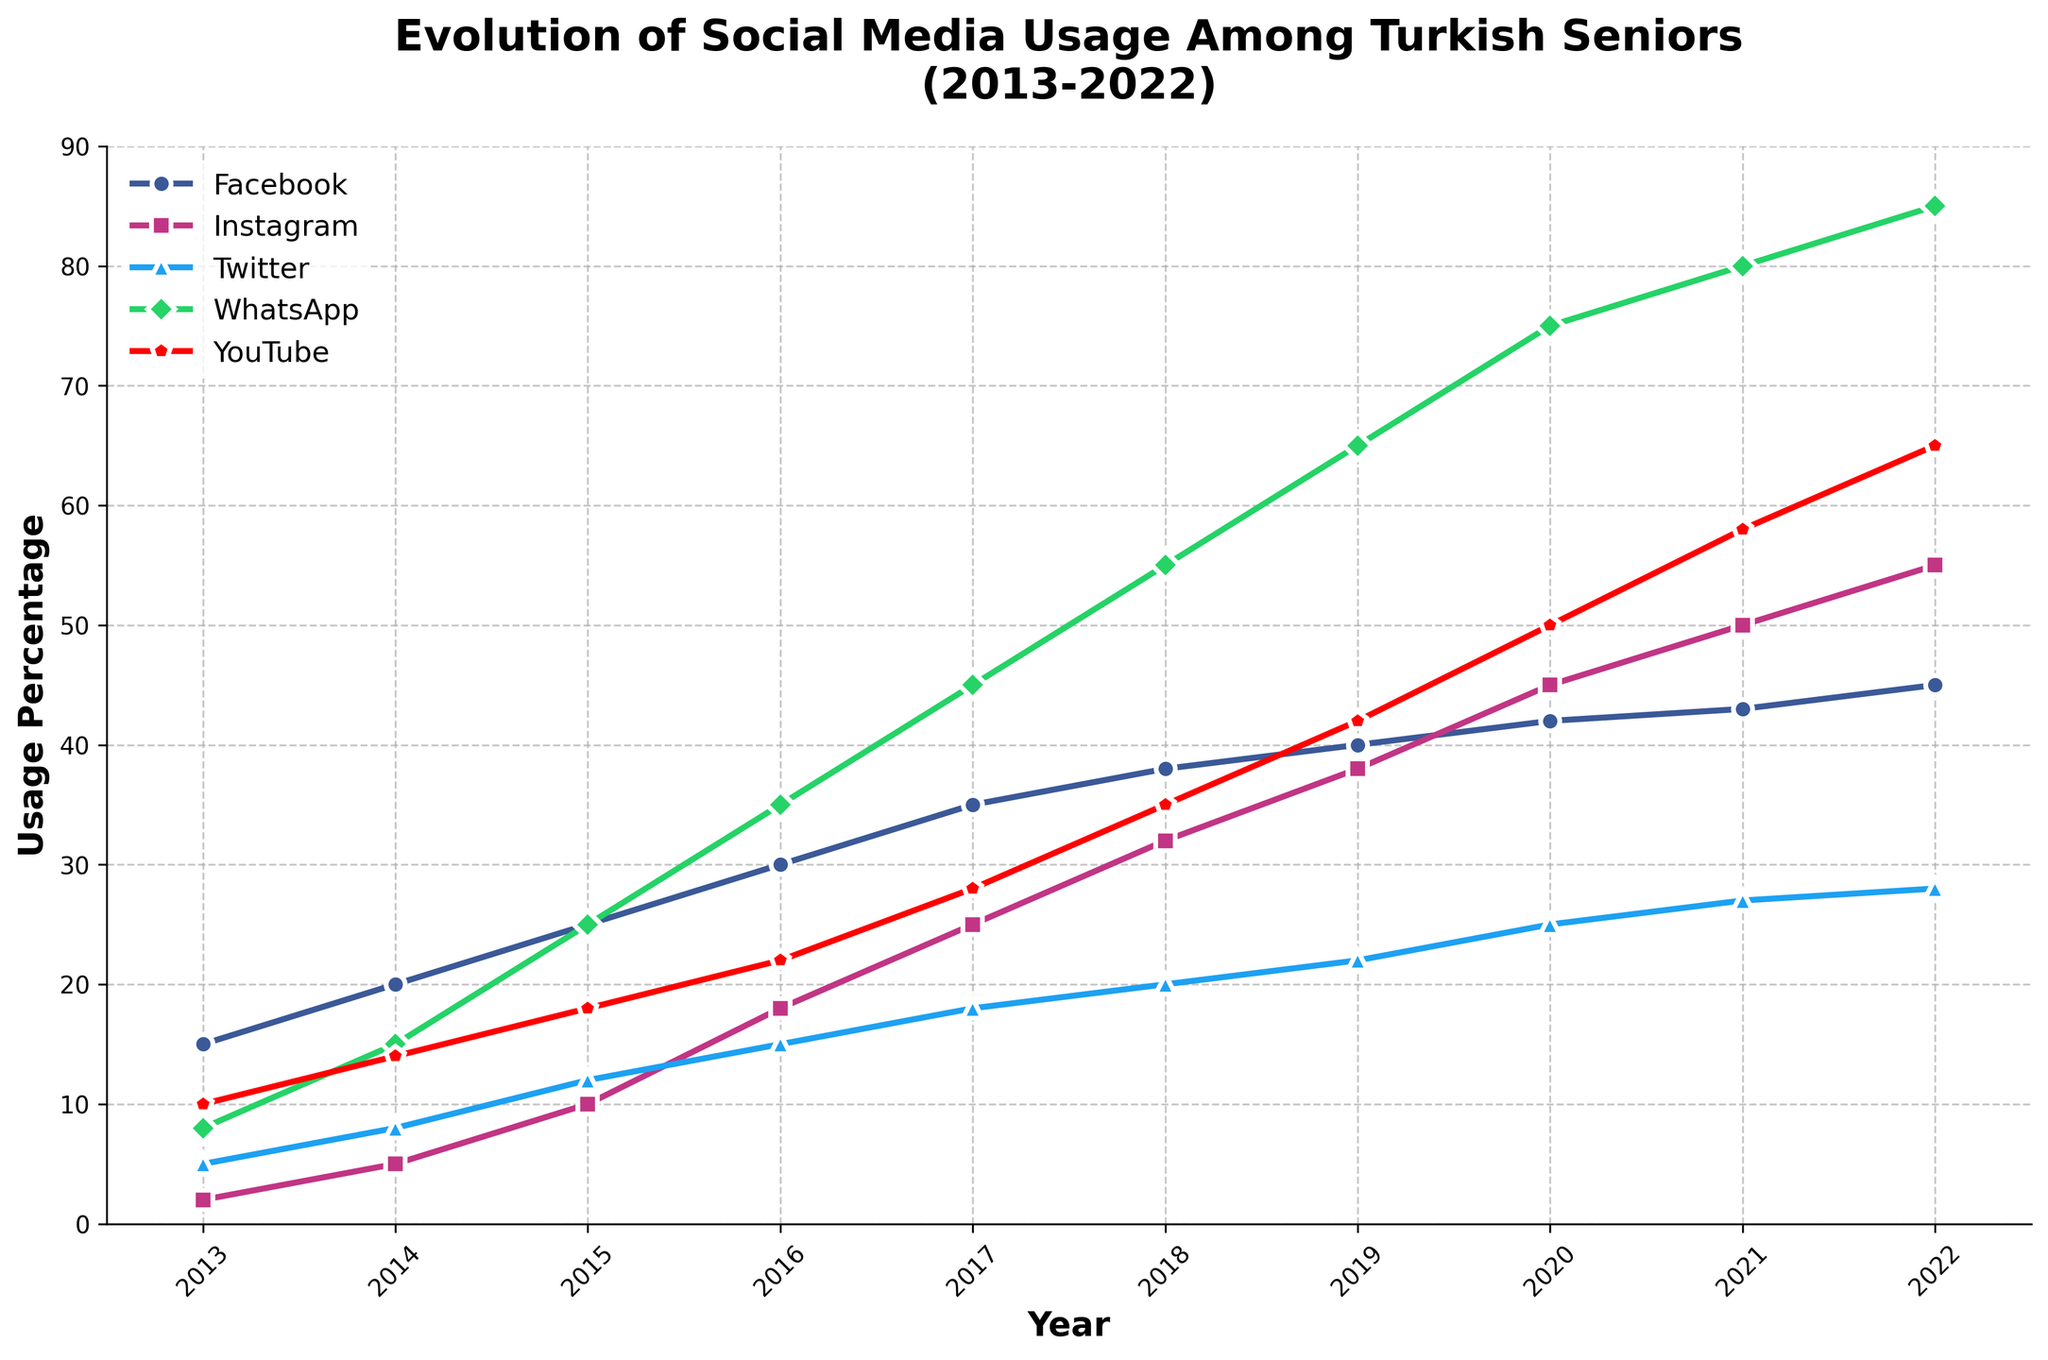What year did Facebook usage among Turkish seniors reach 30%? To find the year when Facebook usage reached 30%, look for the point where the Facebook line crosses the 30% mark on the y-axis. This corresponds to the year 2016.
Answer: 2016 Between Instagram and Twitter, which platform saw the largest increase in usage from 2013 to 2022? Calculate the difference in usage for both platforms from 2013 to 2022. For Instagram: 55 - 2 = 53. For Twitter: 28 - 5 = 23. Instagram saw a larger increase.
Answer: Instagram In which year did WhatsApp overtake YouTube in terms of usage? Identify the year when the green line (WhatsApp) crosses above the red line (YouTube). This crossover happens between 2017 and 2018.
Answer: 2018 What is the average social media usage for Facebook and YouTube in 2020? First, find the values for Facebook and YouTube in 2020 (42 for Facebook and 50 for YouTube). Then calculate the average: (42 + 50) / 2 = 46.
Answer: 46 In 2022, which platform had the lowest usage percentage among Turkish seniors? Look at the 2022 data points for all platforms. The lowest point is for Twitter, with 28%.
Answer: Twitter If the trend from 2013 to 2022 continues, which platform is likely to reach 60% usage first in the subsequent year for the next year (2023)? Extrapolate the trends, noting that WhatsApp is increasing rapidly and closest to 60% by 2022. Therefore, WhatsApp is likely to reach 60% first.
Answer: WhatsApp How much did WhatsApp's usage increase from 2016 to 2022? Calculate the difference in usage for WhatsApp between 2016 and 2022: 85 - 35 = 50.
Answer: 50 During which year did Facebook exceed 40% usage among Turkish seniors? Look for the year when Facebook crosses the 40% mark. This occurs between 2018 and 2019.
Answer: 2019 Compare the growth rate of YouTube and Instagram from 2013 to 2022. Which grew faster? Calculate the differences: YouTube grew from 10 to 65 (55% increase), Instagram from 2 to 55 (53% increase). YouTube grew slightly faster.
Answer: YouTube Identify the only social media platform where usage did not surpass 30% by 2022. Examine the end data points for all platforms in 2022. Twitter is the only one with usage below 30%.
Answer: Twitter 